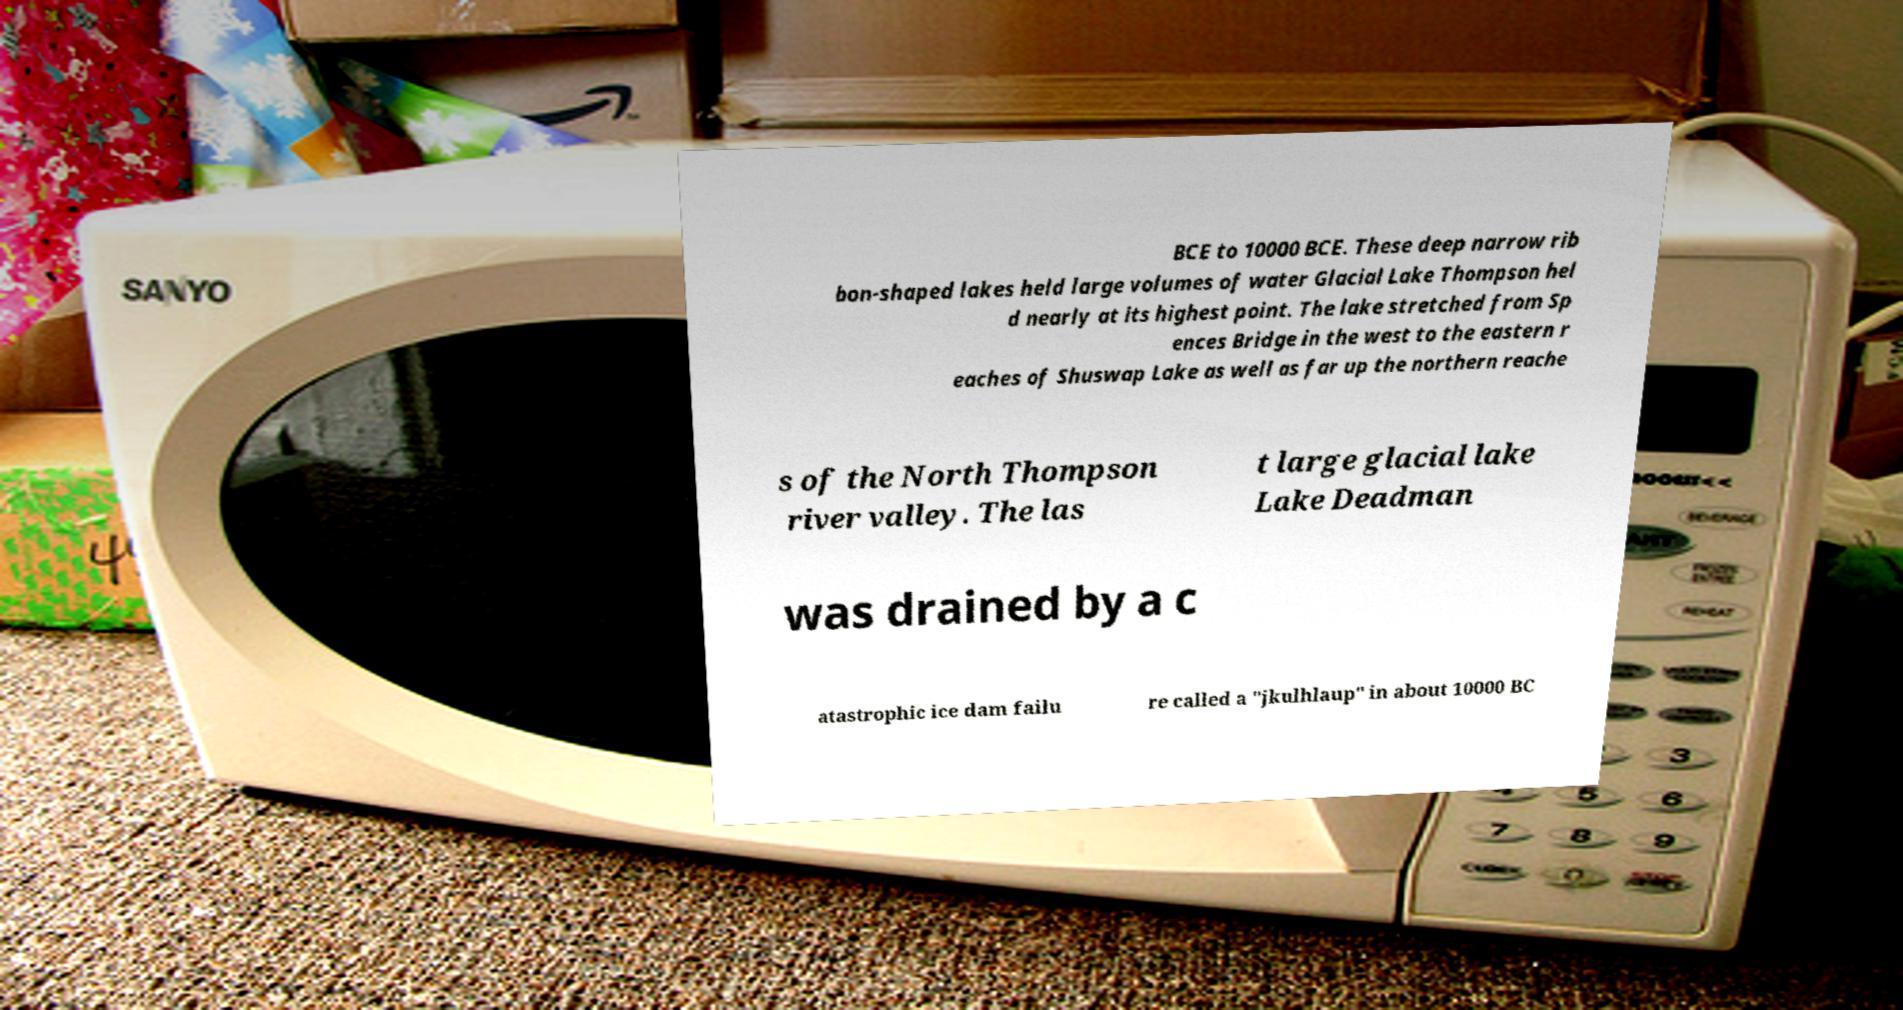Could you extract and type out the text from this image? BCE to 10000 BCE. These deep narrow rib bon-shaped lakes held large volumes of water Glacial Lake Thompson hel d nearly at its highest point. The lake stretched from Sp ences Bridge in the west to the eastern r eaches of Shuswap Lake as well as far up the northern reache s of the North Thompson river valley. The las t large glacial lake Lake Deadman was drained by a c atastrophic ice dam failu re called a "jkulhlaup" in about 10000 BC 